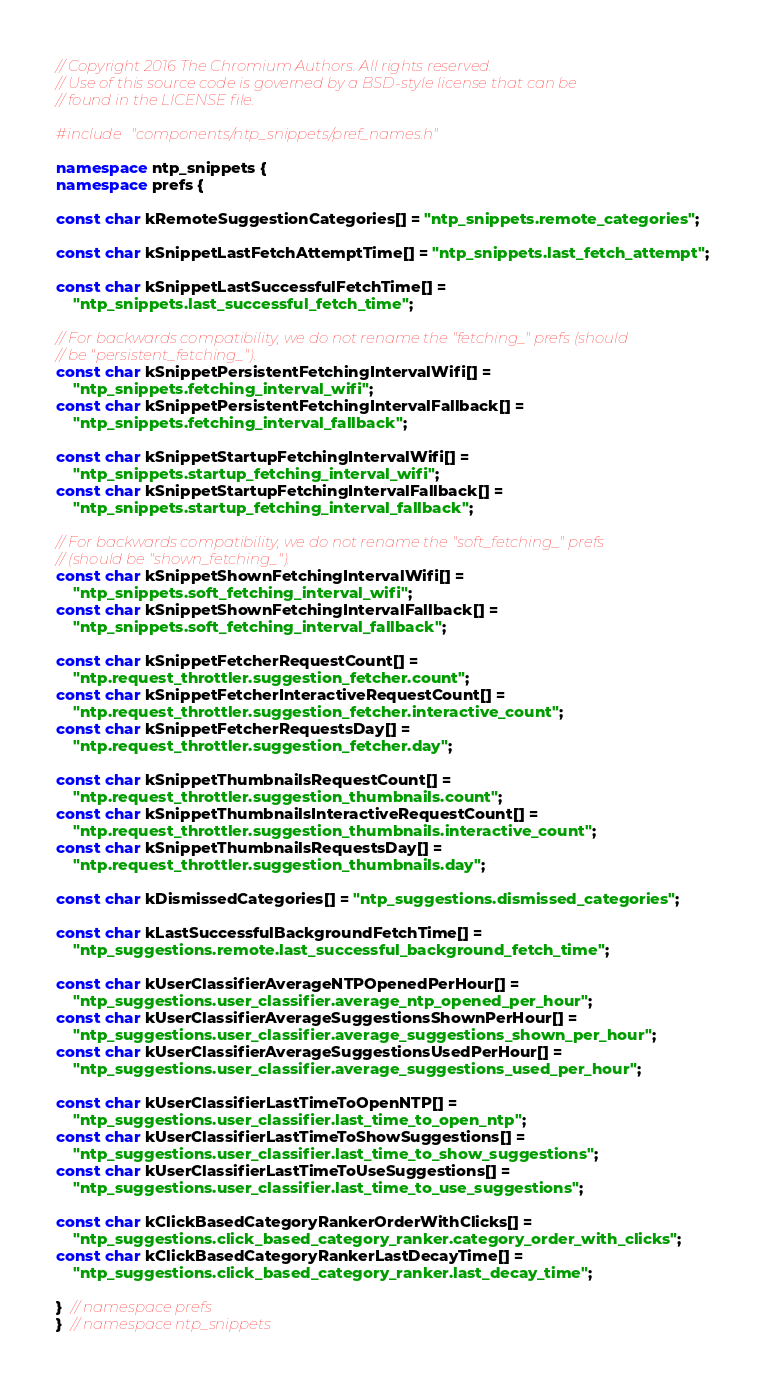<code> <loc_0><loc_0><loc_500><loc_500><_C++_>// Copyright 2016 The Chromium Authors. All rights reserved.
// Use of this source code is governed by a BSD-style license that can be
// found in the LICENSE file.

#include "components/ntp_snippets/pref_names.h"

namespace ntp_snippets {
namespace prefs {

const char kRemoteSuggestionCategories[] = "ntp_snippets.remote_categories";

const char kSnippetLastFetchAttemptTime[] = "ntp_snippets.last_fetch_attempt";

const char kSnippetLastSuccessfulFetchTime[] =
    "ntp_snippets.last_successful_fetch_time";

// For backwards compatibility, we do not rename the "fetching_" prefs (should
// be "persistent_fetching_").
const char kSnippetPersistentFetchingIntervalWifi[] =
    "ntp_snippets.fetching_interval_wifi";
const char kSnippetPersistentFetchingIntervalFallback[] =
    "ntp_snippets.fetching_interval_fallback";

const char kSnippetStartupFetchingIntervalWifi[] =
    "ntp_snippets.startup_fetching_interval_wifi";
const char kSnippetStartupFetchingIntervalFallback[] =
    "ntp_snippets.startup_fetching_interval_fallback";

// For backwards compatibility, we do not rename the "soft_fetching_" prefs
// (should be "shown_fetching_").
const char kSnippetShownFetchingIntervalWifi[] =
    "ntp_snippets.soft_fetching_interval_wifi";
const char kSnippetShownFetchingIntervalFallback[] =
    "ntp_snippets.soft_fetching_interval_fallback";

const char kSnippetFetcherRequestCount[] =
    "ntp.request_throttler.suggestion_fetcher.count";
const char kSnippetFetcherInteractiveRequestCount[] =
    "ntp.request_throttler.suggestion_fetcher.interactive_count";
const char kSnippetFetcherRequestsDay[] =
    "ntp.request_throttler.suggestion_fetcher.day";

const char kSnippetThumbnailsRequestCount[] =
    "ntp.request_throttler.suggestion_thumbnails.count";
const char kSnippetThumbnailsInteractiveRequestCount[] =
    "ntp.request_throttler.suggestion_thumbnails.interactive_count";
const char kSnippetThumbnailsRequestsDay[] =
    "ntp.request_throttler.suggestion_thumbnails.day";

const char kDismissedCategories[] = "ntp_suggestions.dismissed_categories";

const char kLastSuccessfulBackgroundFetchTime[] =
    "ntp_suggestions.remote.last_successful_background_fetch_time";

const char kUserClassifierAverageNTPOpenedPerHour[] =
    "ntp_suggestions.user_classifier.average_ntp_opened_per_hour";
const char kUserClassifierAverageSuggestionsShownPerHour[] =
    "ntp_suggestions.user_classifier.average_suggestions_shown_per_hour";
const char kUserClassifierAverageSuggestionsUsedPerHour[] =
    "ntp_suggestions.user_classifier.average_suggestions_used_per_hour";

const char kUserClassifierLastTimeToOpenNTP[] =
    "ntp_suggestions.user_classifier.last_time_to_open_ntp";
const char kUserClassifierLastTimeToShowSuggestions[] =
    "ntp_suggestions.user_classifier.last_time_to_show_suggestions";
const char kUserClassifierLastTimeToUseSuggestions[] =
    "ntp_suggestions.user_classifier.last_time_to_use_suggestions";

const char kClickBasedCategoryRankerOrderWithClicks[] =
    "ntp_suggestions.click_based_category_ranker.category_order_with_clicks";
const char kClickBasedCategoryRankerLastDecayTime[] =
    "ntp_suggestions.click_based_category_ranker.last_decay_time";

}  // namespace prefs
}  // namespace ntp_snippets
</code> 